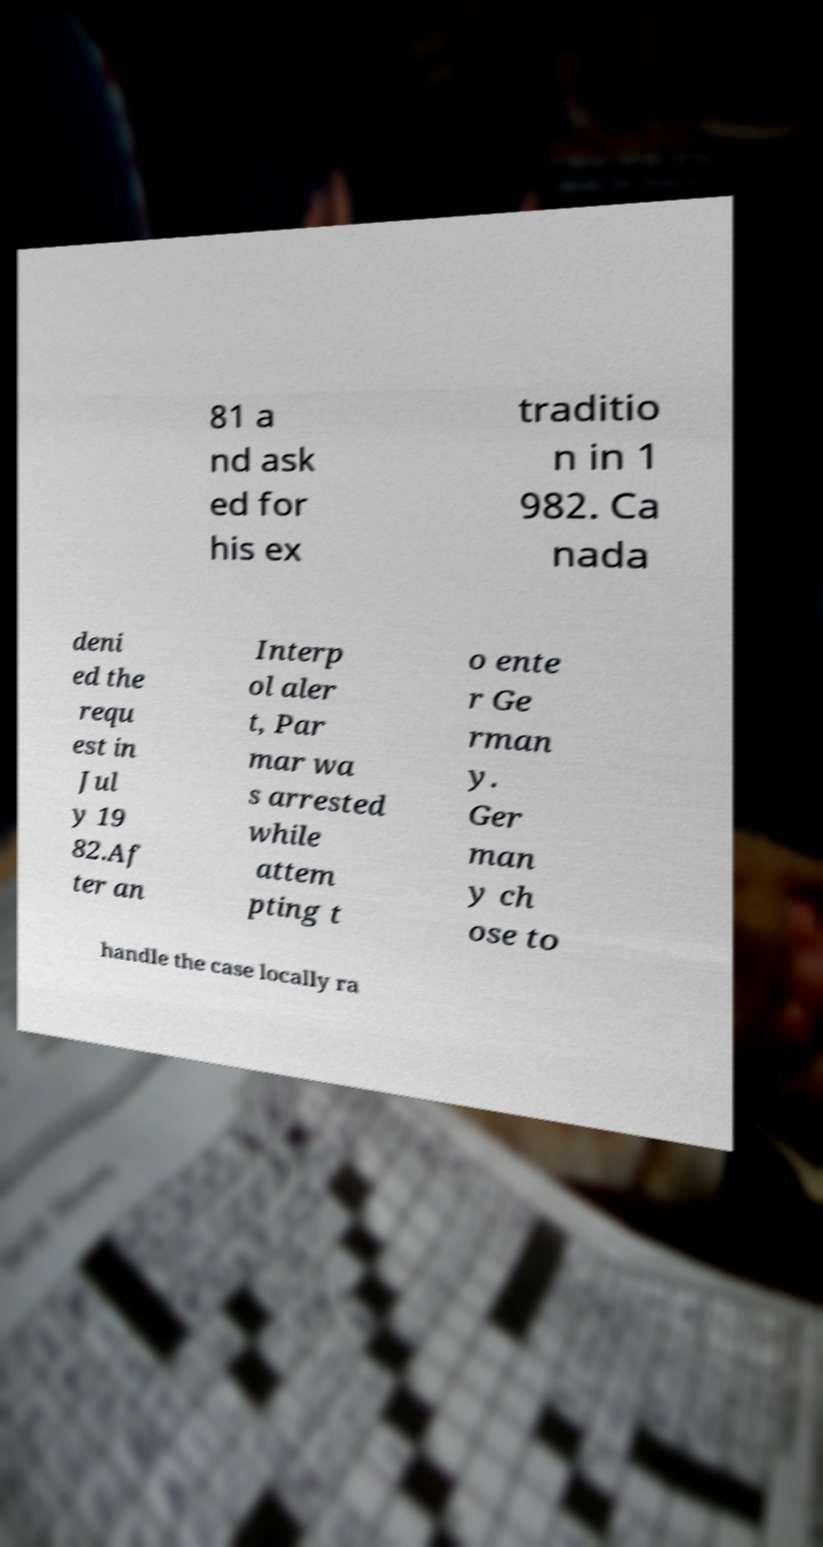Could you assist in decoding the text presented in this image and type it out clearly? 81 a nd ask ed for his ex traditio n in 1 982. Ca nada deni ed the requ est in Jul y 19 82.Af ter an Interp ol aler t, Par mar wa s arrested while attem pting t o ente r Ge rman y. Ger man y ch ose to handle the case locally ra 